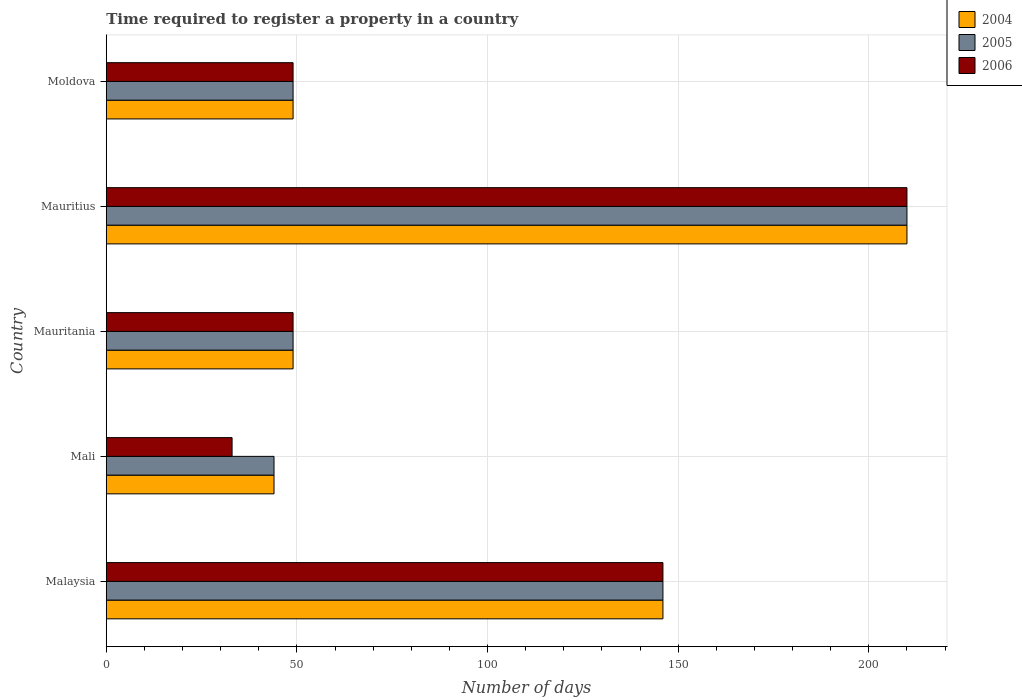How many groups of bars are there?
Provide a succinct answer. 5. Are the number of bars per tick equal to the number of legend labels?
Offer a terse response. Yes. How many bars are there on the 1st tick from the top?
Provide a succinct answer. 3. What is the label of the 5th group of bars from the top?
Your answer should be compact. Malaysia. What is the number of days required to register a property in 2004 in Mauritius?
Your response must be concise. 210. Across all countries, what is the maximum number of days required to register a property in 2005?
Make the answer very short. 210. Across all countries, what is the minimum number of days required to register a property in 2004?
Offer a terse response. 44. In which country was the number of days required to register a property in 2004 maximum?
Offer a very short reply. Mauritius. In which country was the number of days required to register a property in 2004 minimum?
Your answer should be very brief. Mali. What is the total number of days required to register a property in 2006 in the graph?
Keep it short and to the point. 487. What is the difference between the number of days required to register a property in 2006 in Mauritania and that in Moldova?
Keep it short and to the point. 0. What is the difference between the number of days required to register a property in 2005 in Mauritius and the number of days required to register a property in 2006 in Mali?
Give a very brief answer. 177. What is the average number of days required to register a property in 2004 per country?
Keep it short and to the point. 99.6. What is the ratio of the number of days required to register a property in 2005 in Mauritius to that in Moldova?
Make the answer very short. 4.29. What is the difference between the highest and the lowest number of days required to register a property in 2006?
Your response must be concise. 177. In how many countries, is the number of days required to register a property in 2005 greater than the average number of days required to register a property in 2005 taken over all countries?
Ensure brevity in your answer.  2. What does the 3rd bar from the top in Malaysia represents?
Provide a succinct answer. 2004. Is it the case that in every country, the sum of the number of days required to register a property in 2006 and number of days required to register a property in 2005 is greater than the number of days required to register a property in 2004?
Provide a succinct answer. Yes. Are all the bars in the graph horizontal?
Provide a succinct answer. Yes. How many countries are there in the graph?
Your response must be concise. 5. Are the values on the major ticks of X-axis written in scientific E-notation?
Make the answer very short. No. What is the title of the graph?
Give a very brief answer. Time required to register a property in a country. Does "1976" appear as one of the legend labels in the graph?
Your answer should be compact. No. What is the label or title of the X-axis?
Make the answer very short. Number of days. What is the Number of days of 2004 in Malaysia?
Keep it short and to the point. 146. What is the Number of days of 2005 in Malaysia?
Offer a very short reply. 146. What is the Number of days in 2006 in Malaysia?
Offer a terse response. 146. What is the Number of days in 2004 in Mali?
Your answer should be compact. 44. What is the Number of days of 2006 in Mali?
Make the answer very short. 33. What is the Number of days in 2004 in Mauritania?
Keep it short and to the point. 49. What is the Number of days in 2004 in Mauritius?
Your response must be concise. 210. What is the Number of days of 2005 in Mauritius?
Your response must be concise. 210. What is the Number of days of 2006 in Mauritius?
Make the answer very short. 210. What is the Number of days of 2006 in Moldova?
Make the answer very short. 49. Across all countries, what is the maximum Number of days of 2004?
Your response must be concise. 210. Across all countries, what is the maximum Number of days of 2005?
Provide a succinct answer. 210. Across all countries, what is the maximum Number of days of 2006?
Your answer should be compact. 210. Across all countries, what is the minimum Number of days of 2006?
Ensure brevity in your answer.  33. What is the total Number of days in 2004 in the graph?
Provide a succinct answer. 498. What is the total Number of days of 2005 in the graph?
Your response must be concise. 498. What is the total Number of days in 2006 in the graph?
Ensure brevity in your answer.  487. What is the difference between the Number of days of 2004 in Malaysia and that in Mali?
Ensure brevity in your answer.  102. What is the difference between the Number of days in 2005 in Malaysia and that in Mali?
Your response must be concise. 102. What is the difference between the Number of days in 2006 in Malaysia and that in Mali?
Your response must be concise. 113. What is the difference between the Number of days in 2004 in Malaysia and that in Mauritania?
Provide a succinct answer. 97. What is the difference between the Number of days in 2005 in Malaysia and that in Mauritania?
Your answer should be compact. 97. What is the difference between the Number of days of 2006 in Malaysia and that in Mauritania?
Provide a succinct answer. 97. What is the difference between the Number of days of 2004 in Malaysia and that in Mauritius?
Give a very brief answer. -64. What is the difference between the Number of days of 2005 in Malaysia and that in Mauritius?
Provide a short and direct response. -64. What is the difference between the Number of days in 2006 in Malaysia and that in Mauritius?
Offer a terse response. -64. What is the difference between the Number of days of 2004 in Malaysia and that in Moldova?
Offer a very short reply. 97. What is the difference between the Number of days of 2005 in Malaysia and that in Moldova?
Offer a very short reply. 97. What is the difference between the Number of days of 2006 in Malaysia and that in Moldova?
Keep it short and to the point. 97. What is the difference between the Number of days in 2004 in Mali and that in Mauritania?
Offer a terse response. -5. What is the difference between the Number of days in 2005 in Mali and that in Mauritania?
Provide a short and direct response. -5. What is the difference between the Number of days in 2006 in Mali and that in Mauritania?
Keep it short and to the point. -16. What is the difference between the Number of days of 2004 in Mali and that in Mauritius?
Make the answer very short. -166. What is the difference between the Number of days of 2005 in Mali and that in Mauritius?
Your answer should be compact. -166. What is the difference between the Number of days of 2006 in Mali and that in Mauritius?
Make the answer very short. -177. What is the difference between the Number of days in 2006 in Mali and that in Moldova?
Your answer should be very brief. -16. What is the difference between the Number of days of 2004 in Mauritania and that in Mauritius?
Ensure brevity in your answer.  -161. What is the difference between the Number of days of 2005 in Mauritania and that in Mauritius?
Keep it short and to the point. -161. What is the difference between the Number of days in 2006 in Mauritania and that in Mauritius?
Offer a very short reply. -161. What is the difference between the Number of days in 2004 in Mauritania and that in Moldova?
Keep it short and to the point. 0. What is the difference between the Number of days in 2005 in Mauritania and that in Moldova?
Offer a very short reply. 0. What is the difference between the Number of days of 2006 in Mauritania and that in Moldova?
Offer a terse response. 0. What is the difference between the Number of days in 2004 in Mauritius and that in Moldova?
Provide a succinct answer. 161. What is the difference between the Number of days in 2005 in Mauritius and that in Moldova?
Give a very brief answer. 161. What is the difference between the Number of days in 2006 in Mauritius and that in Moldova?
Ensure brevity in your answer.  161. What is the difference between the Number of days in 2004 in Malaysia and the Number of days in 2005 in Mali?
Keep it short and to the point. 102. What is the difference between the Number of days of 2004 in Malaysia and the Number of days of 2006 in Mali?
Keep it short and to the point. 113. What is the difference between the Number of days in 2005 in Malaysia and the Number of days in 2006 in Mali?
Provide a succinct answer. 113. What is the difference between the Number of days in 2004 in Malaysia and the Number of days in 2005 in Mauritania?
Make the answer very short. 97. What is the difference between the Number of days in 2004 in Malaysia and the Number of days in 2006 in Mauritania?
Your response must be concise. 97. What is the difference between the Number of days in 2005 in Malaysia and the Number of days in 2006 in Mauritania?
Keep it short and to the point. 97. What is the difference between the Number of days of 2004 in Malaysia and the Number of days of 2005 in Mauritius?
Your response must be concise. -64. What is the difference between the Number of days in 2004 in Malaysia and the Number of days in 2006 in Mauritius?
Offer a terse response. -64. What is the difference between the Number of days of 2005 in Malaysia and the Number of days of 2006 in Mauritius?
Make the answer very short. -64. What is the difference between the Number of days in 2004 in Malaysia and the Number of days in 2005 in Moldova?
Make the answer very short. 97. What is the difference between the Number of days of 2004 in Malaysia and the Number of days of 2006 in Moldova?
Make the answer very short. 97. What is the difference between the Number of days of 2005 in Malaysia and the Number of days of 2006 in Moldova?
Offer a terse response. 97. What is the difference between the Number of days of 2004 in Mali and the Number of days of 2006 in Mauritania?
Offer a very short reply. -5. What is the difference between the Number of days in 2004 in Mali and the Number of days in 2005 in Mauritius?
Your answer should be compact. -166. What is the difference between the Number of days in 2004 in Mali and the Number of days in 2006 in Mauritius?
Offer a very short reply. -166. What is the difference between the Number of days in 2005 in Mali and the Number of days in 2006 in Mauritius?
Your answer should be compact. -166. What is the difference between the Number of days of 2005 in Mali and the Number of days of 2006 in Moldova?
Offer a terse response. -5. What is the difference between the Number of days in 2004 in Mauritania and the Number of days in 2005 in Mauritius?
Provide a short and direct response. -161. What is the difference between the Number of days in 2004 in Mauritania and the Number of days in 2006 in Mauritius?
Keep it short and to the point. -161. What is the difference between the Number of days of 2005 in Mauritania and the Number of days of 2006 in Mauritius?
Provide a short and direct response. -161. What is the difference between the Number of days in 2004 in Mauritania and the Number of days in 2006 in Moldova?
Provide a short and direct response. 0. What is the difference between the Number of days in 2005 in Mauritania and the Number of days in 2006 in Moldova?
Offer a very short reply. 0. What is the difference between the Number of days in 2004 in Mauritius and the Number of days in 2005 in Moldova?
Offer a very short reply. 161. What is the difference between the Number of days of 2004 in Mauritius and the Number of days of 2006 in Moldova?
Give a very brief answer. 161. What is the difference between the Number of days of 2005 in Mauritius and the Number of days of 2006 in Moldova?
Provide a succinct answer. 161. What is the average Number of days in 2004 per country?
Give a very brief answer. 99.6. What is the average Number of days of 2005 per country?
Your answer should be compact. 99.6. What is the average Number of days in 2006 per country?
Offer a terse response. 97.4. What is the difference between the Number of days in 2004 and Number of days in 2005 in Malaysia?
Provide a short and direct response. 0. What is the difference between the Number of days of 2004 and Number of days of 2005 in Mali?
Ensure brevity in your answer.  0. What is the difference between the Number of days in 2004 and Number of days in 2006 in Mali?
Give a very brief answer. 11. What is the difference between the Number of days in 2004 and Number of days in 2005 in Mauritania?
Make the answer very short. 0. What is the difference between the Number of days of 2004 and Number of days of 2006 in Mauritania?
Give a very brief answer. 0. What is the difference between the Number of days in 2005 and Number of days in 2006 in Mauritania?
Your answer should be compact. 0. What is the difference between the Number of days of 2004 and Number of days of 2005 in Mauritius?
Ensure brevity in your answer.  0. What is the difference between the Number of days in 2004 and Number of days in 2006 in Moldova?
Provide a succinct answer. 0. What is the difference between the Number of days in 2005 and Number of days in 2006 in Moldova?
Make the answer very short. 0. What is the ratio of the Number of days in 2004 in Malaysia to that in Mali?
Give a very brief answer. 3.32. What is the ratio of the Number of days in 2005 in Malaysia to that in Mali?
Your answer should be compact. 3.32. What is the ratio of the Number of days in 2006 in Malaysia to that in Mali?
Your response must be concise. 4.42. What is the ratio of the Number of days in 2004 in Malaysia to that in Mauritania?
Offer a very short reply. 2.98. What is the ratio of the Number of days of 2005 in Malaysia to that in Mauritania?
Give a very brief answer. 2.98. What is the ratio of the Number of days of 2006 in Malaysia to that in Mauritania?
Ensure brevity in your answer.  2.98. What is the ratio of the Number of days of 2004 in Malaysia to that in Mauritius?
Offer a very short reply. 0.7. What is the ratio of the Number of days of 2005 in Malaysia to that in Mauritius?
Offer a very short reply. 0.7. What is the ratio of the Number of days of 2006 in Malaysia to that in Mauritius?
Make the answer very short. 0.7. What is the ratio of the Number of days of 2004 in Malaysia to that in Moldova?
Your answer should be compact. 2.98. What is the ratio of the Number of days of 2005 in Malaysia to that in Moldova?
Your answer should be compact. 2.98. What is the ratio of the Number of days of 2006 in Malaysia to that in Moldova?
Keep it short and to the point. 2.98. What is the ratio of the Number of days of 2004 in Mali to that in Mauritania?
Your answer should be compact. 0.9. What is the ratio of the Number of days in 2005 in Mali to that in Mauritania?
Your response must be concise. 0.9. What is the ratio of the Number of days in 2006 in Mali to that in Mauritania?
Keep it short and to the point. 0.67. What is the ratio of the Number of days in 2004 in Mali to that in Mauritius?
Your response must be concise. 0.21. What is the ratio of the Number of days of 2005 in Mali to that in Mauritius?
Your answer should be very brief. 0.21. What is the ratio of the Number of days of 2006 in Mali to that in Mauritius?
Provide a short and direct response. 0.16. What is the ratio of the Number of days in 2004 in Mali to that in Moldova?
Provide a succinct answer. 0.9. What is the ratio of the Number of days of 2005 in Mali to that in Moldova?
Ensure brevity in your answer.  0.9. What is the ratio of the Number of days of 2006 in Mali to that in Moldova?
Your answer should be compact. 0.67. What is the ratio of the Number of days of 2004 in Mauritania to that in Mauritius?
Make the answer very short. 0.23. What is the ratio of the Number of days in 2005 in Mauritania to that in Mauritius?
Ensure brevity in your answer.  0.23. What is the ratio of the Number of days of 2006 in Mauritania to that in Mauritius?
Provide a succinct answer. 0.23. What is the ratio of the Number of days of 2004 in Mauritania to that in Moldova?
Make the answer very short. 1. What is the ratio of the Number of days of 2005 in Mauritania to that in Moldova?
Your response must be concise. 1. What is the ratio of the Number of days of 2006 in Mauritania to that in Moldova?
Your response must be concise. 1. What is the ratio of the Number of days in 2004 in Mauritius to that in Moldova?
Your response must be concise. 4.29. What is the ratio of the Number of days in 2005 in Mauritius to that in Moldova?
Offer a very short reply. 4.29. What is the ratio of the Number of days in 2006 in Mauritius to that in Moldova?
Offer a terse response. 4.29. What is the difference between the highest and the second highest Number of days in 2005?
Provide a short and direct response. 64. What is the difference between the highest and the second highest Number of days of 2006?
Offer a terse response. 64. What is the difference between the highest and the lowest Number of days of 2004?
Give a very brief answer. 166. What is the difference between the highest and the lowest Number of days in 2005?
Ensure brevity in your answer.  166. What is the difference between the highest and the lowest Number of days of 2006?
Offer a very short reply. 177. 